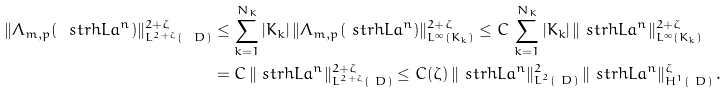<formula> <loc_0><loc_0><loc_500><loc_500>\| \Lambda _ { m , p } ( \ s t r h L a ^ { n } ) \| _ { L ^ { 2 + \zeta } ( \ D ) } ^ { 2 + \zeta } & \leq \sum _ { k = 1 } ^ { N _ { K } } | K _ { k } | \, \| \Lambda _ { m , p } ( \ s t r h L a ^ { n } ) \| _ { L ^ { \infty } ( K _ { k } ) } ^ { 2 + \zeta } \leq C \, \sum _ { k = 1 } ^ { N _ { K } } | K _ { k } | \, \| \ s t r h L a ^ { n } \| _ { L ^ { \infty } ( K _ { k } ) } ^ { 2 + \zeta } \\ & = C \, \| \ s t r h L a ^ { n } \| _ { L ^ { 2 + \zeta } ( \ D ) } ^ { 2 + \zeta } \leq C ( \zeta ) \, \| \ s t r h L a ^ { n } \| _ { L ^ { 2 } ( \ D ) } ^ { 2 } \, \| \ s t r h L a ^ { n } \| _ { H ^ { 1 } ( \ D ) } ^ { \zeta } \, .</formula> 